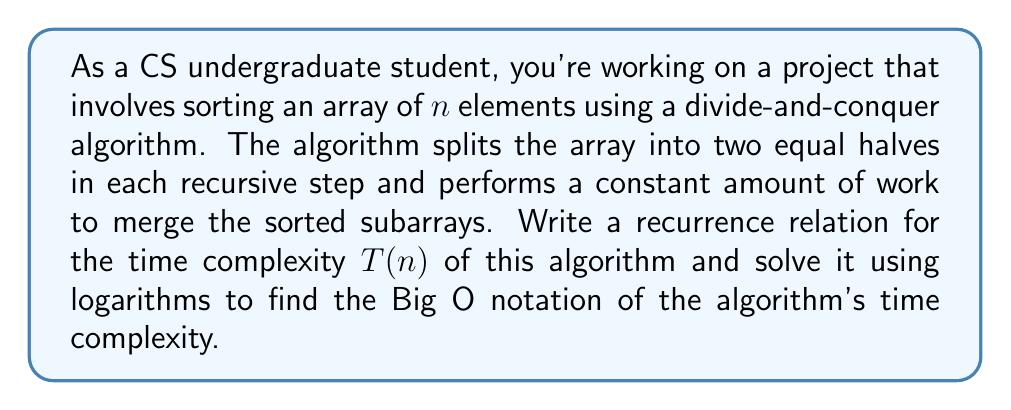Could you help me with this problem? Let's approach this step-by-step:

1) First, we need to write the recurrence relation. Given the description:
   - The algorithm divides the array into two equal halves, so we have $T(n/2)$ twice.
   - There's a constant amount of work to merge, let's call it $c \cdot n$.

   The recurrence relation is:
   
   $$T(n) = 2T(n/2) + cn$$

2) To solve this, we can use the Master Theorem, but let's solve it using logarithms as requested.

3) Let's guess that the solution is of the form $T(n) = an \log n + bn$ where $a$ and $b$ are constants we need to determine.

4) Substituting this into our recurrence:

   $$an \log n + bn = 2(a(n/2) \log(n/2) + b(n/2)) + cn$$

5) Simplify the right side:

   $$an \log n + bn = an \log(n/2) + bn + cn$$

6) Using the logarithm property $\log(n/2) = \log n - \log 2 = \log n - 1$:

   $$an \log n + bn = an \log n - an + bn + cn$$

7) The $an \log n$ terms cancel out on both sides:

   $$bn = -an + bn + cn$$

8) Simplify:

   $$0 = -an + cn$$
   $$an = cn$$
   $$a = c$$

9) We've determined that $a = c$, but $b$ can be any constant. This means our solution is of the form:

   $$T(n) = cn \log n + bn$$

10) In Big O notation, we drop lower-order terms and constants, so:

    $$T(n) = O(n \log n)$$

This is indeed the time complexity of well-known divide-and-conquer sorting algorithms like Merge Sort and Quick Sort (average case).
Answer: The time complexity of the algorithm is $O(n \log n)$. 